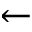<formula> <loc_0><loc_0><loc_500><loc_500>\leftarrow</formula> 